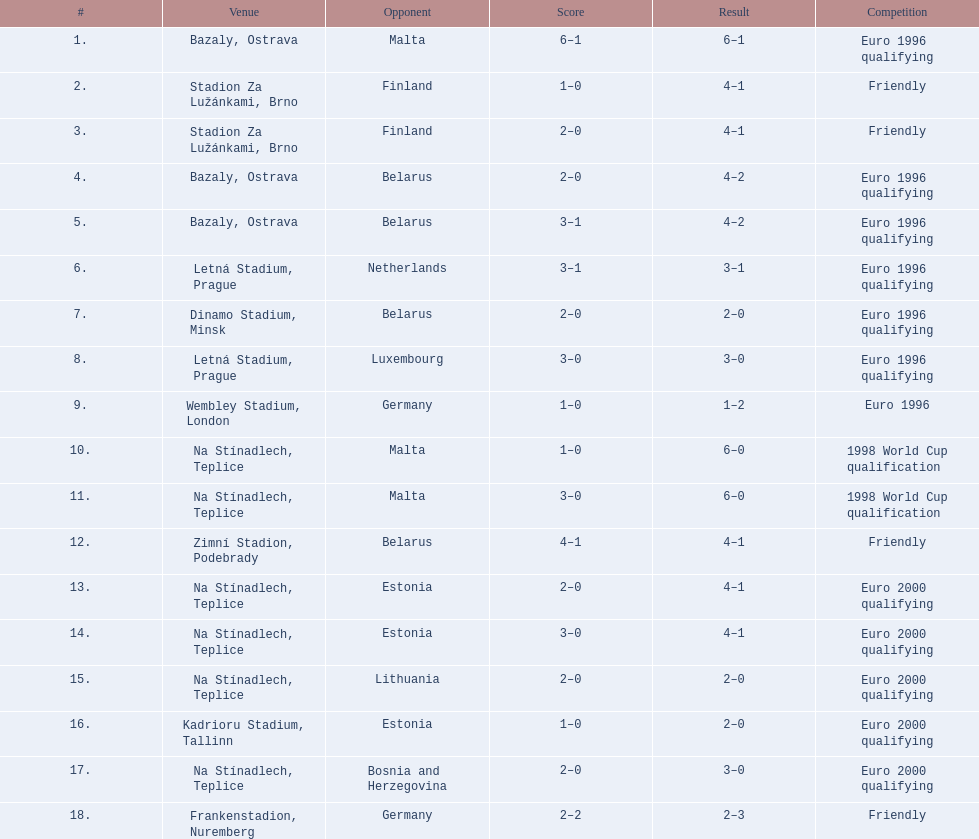Name the competitors taking part in the amicable competition. Finland, Belarus, Germany. 